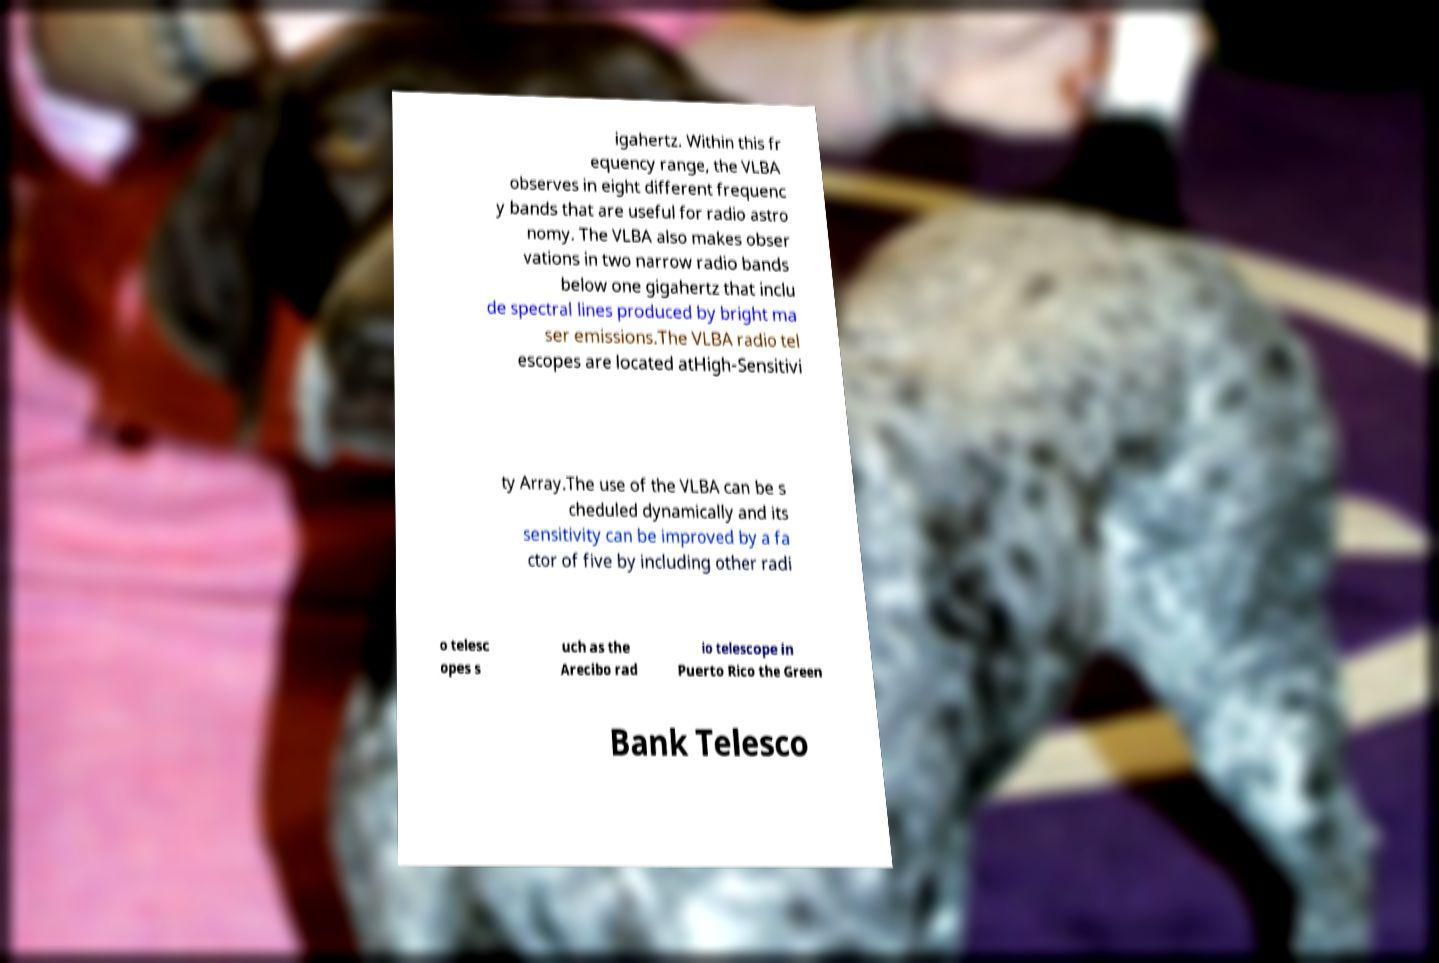Can you read and provide the text displayed in the image?This photo seems to have some interesting text. Can you extract and type it out for me? igahertz. Within this fr equency range, the VLBA observes in eight different frequenc y bands that are useful for radio astro nomy. The VLBA also makes obser vations in two narrow radio bands below one gigahertz that inclu de spectral lines produced by bright ma ser emissions.The VLBA radio tel escopes are located atHigh-Sensitivi ty Array.The use of the VLBA can be s cheduled dynamically and its sensitivity can be improved by a fa ctor of five by including other radi o telesc opes s uch as the Arecibo rad io telescope in Puerto Rico the Green Bank Telesco 